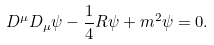Convert formula to latex. <formula><loc_0><loc_0><loc_500><loc_500>D ^ { \mu } D _ { \mu } \psi - \frac { 1 } { 4 } R \psi + m ^ { 2 } \psi = 0 .</formula> 